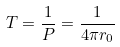<formula> <loc_0><loc_0><loc_500><loc_500>T = \frac { 1 } { P } = \frac { 1 } { 4 \pi r _ { 0 } }</formula> 